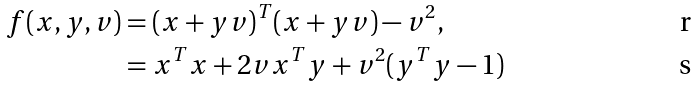<formula> <loc_0><loc_0><loc_500><loc_500>f ( x , y , v ) & = ( x + y v ) ^ { T } ( x + y v ) - v ^ { 2 } , \\ & = x ^ { T } x + 2 v x ^ { T } y + v ^ { 2 } ( y ^ { T } y - 1 )</formula> 